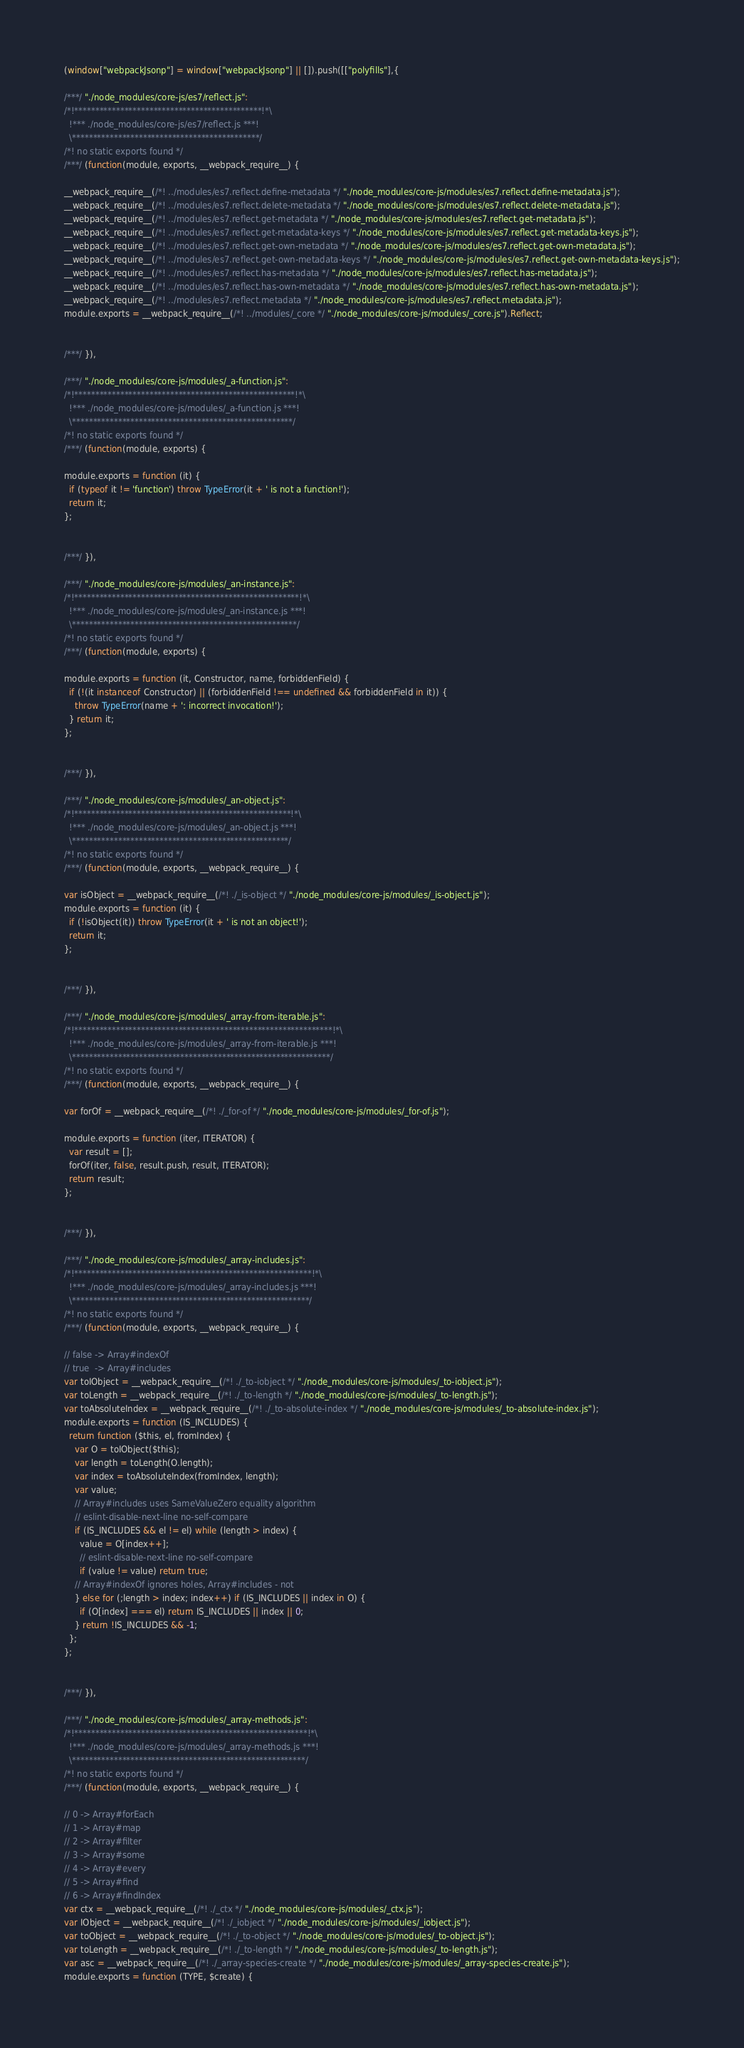Convert code to text. <code><loc_0><loc_0><loc_500><loc_500><_JavaScript_>(window["webpackJsonp"] = window["webpackJsonp"] || []).push([["polyfills"],{

/***/ "./node_modules/core-js/es7/reflect.js":
/*!*********************************************!*\
  !*** ./node_modules/core-js/es7/reflect.js ***!
  \*********************************************/
/*! no static exports found */
/***/ (function(module, exports, __webpack_require__) {

__webpack_require__(/*! ../modules/es7.reflect.define-metadata */ "./node_modules/core-js/modules/es7.reflect.define-metadata.js");
__webpack_require__(/*! ../modules/es7.reflect.delete-metadata */ "./node_modules/core-js/modules/es7.reflect.delete-metadata.js");
__webpack_require__(/*! ../modules/es7.reflect.get-metadata */ "./node_modules/core-js/modules/es7.reflect.get-metadata.js");
__webpack_require__(/*! ../modules/es7.reflect.get-metadata-keys */ "./node_modules/core-js/modules/es7.reflect.get-metadata-keys.js");
__webpack_require__(/*! ../modules/es7.reflect.get-own-metadata */ "./node_modules/core-js/modules/es7.reflect.get-own-metadata.js");
__webpack_require__(/*! ../modules/es7.reflect.get-own-metadata-keys */ "./node_modules/core-js/modules/es7.reflect.get-own-metadata-keys.js");
__webpack_require__(/*! ../modules/es7.reflect.has-metadata */ "./node_modules/core-js/modules/es7.reflect.has-metadata.js");
__webpack_require__(/*! ../modules/es7.reflect.has-own-metadata */ "./node_modules/core-js/modules/es7.reflect.has-own-metadata.js");
__webpack_require__(/*! ../modules/es7.reflect.metadata */ "./node_modules/core-js/modules/es7.reflect.metadata.js");
module.exports = __webpack_require__(/*! ../modules/_core */ "./node_modules/core-js/modules/_core.js").Reflect;


/***/ }),

/***/ "./node_modules/core-js/modules/_a-function.js":
/*!*****************************************************!*\
  !*** ./node_modules/core-js/modules/_a-function.js ***!
  \*****************************************************/
/*! no static exports found */
/***/ (function(module, exports) {

module.exports = function (it) {
  if (typeof it != 'function') throw TypeError(it + ' is not a function!');
  return it;
};


/***/ }),

/***/ "./node_modules/core-js/modules/_an-instance.js":
/*!******************************************************!*\
  !*** ./node_modules/core-js/modules/_an-instance.js ***!
  \******************************************************/
/*! no static exports found */
/***/ (function(module, exports) {

module.exports = function (it, Constructor, name, forbiddenField) {
  if (!(it instanceof Constructor) || (forbiddenField !== undefined && forbiddenField in it)) {
    throw TypeError(name + ': incorrect invocation!');
  } return it;
};


/***/ }),

/***/ "./node_modules/core-js/modules/_an-object.js":
/*!****************************************************!*\
  !*** ./node_modules/core-js/modules/_an-object.js ***!
  \****************************************************/
/*! no static exports found */
/***/ (function(module, exports, __webpack_require__) {

var isObject = __webpack_require__(/*! ./_is-object */ "./node_modules/core-js/modules/_is-object.js");
module.exports = function (it) {
  if (!isObject(it)) throw TypeError(it + ' is not an object!');
  return it;
};


/***/ }),

/***/ "./node_modules/core-js/modules/_array-from-iterable.js":
/*!**************************************************************!*\
  !*** ./node_modules/core-js/modules/_array-from-iterable.js ***!
  \**************************************************************/
/*! no static exports found */
/***/ (function(module, exports, __webpack_require__) {

var forOf = __webpack_require__(/*! ./_for-of */ "./node_modules/core-js/modules/_for-of.js");

module.exports = function (iter, ITERATOR) {
  var result = [];
  forOf(iter, false, result.push, result, ITERATOR);
  return result;
};


/***/ }),

/***/ "./node_modules/core-js/modules/_array-includes.js":
/*!*********************************************************!*\
  !*** ./node_modules/core-js/modules/_array-includes.js ***!
  \*********************************************************/
/*! no static exports found */
/***/ (function(module, exports, __webpack_require__) {

// false -> Array#indexOf
// true  -> Array#includes
var toIObject = __webpack_require__(/*! ./_to-iobject */ "./node_modules/core-js/modules/_to-iobject.js");
var toLength = __webpack_require__(/*! ./_to-length */ "./node_modules/core-js/modules/_to-length.js");
var toAbsoluteIndex = __webpack_require__(/*! ./_to-absolute-index */ "./node_modules/core-js/modules/_to-absolute-index.js");
module.exports = function (IS_INCLUDES) {
  return function ($this, el, fromIndex) {
    var O = toIObject($this);
    var length = toLength(O.length);
    var index = toAbsoluteIndex(fromIndex, length);
    var value;
    // Array#includes uses SameValueZero equality algorithm
    // eslint-disable-next-line no-self-compare
    if (IS_INCLUDES && el != el) while (length > index) {
      value = O[index++];
      // eslint-disable-next-line no-self-compare
      if (value != value) return true;
    // Array#indexOf ignores holes, Array#includes - not
    } else for (;length > index; index++) if (IS_INCLUDES || index in O) {
      if (O[index] === el) return IS_INCLUDES || index || 0;
    } return !IS_INCLUDES && -1;
  };
};


/***/ }),

/***/ "./node_modules/core-js/modules/_array-methods.js":
/*!********************************************************!*\
  !*** ./node_modules/core-js/modules/_array-methods.js ***!
  \********************************************************/
/*! no static exports found */
/***/ (function(module, exports, __webpack_require__) {

// 0 -> Array#forEach
// 1 -> Array#map
// 2 -> Array#filter
// 3 -> Array#some
// 4 -> Array#every
// 5 -> Array#find
// 6 -> Array#findIndex
var ctx = __webpack_require__(/*! ./_ctx */ "./node_modules/core-js/modules/_ctx.js");
var IObject = __webpack_require__(/*! ./_iobject */ "./node_modules/core-js/modules/_iobject.js");
var toObject = __webpack_require__(/*! ./_to-object */ "./node_modules/core-js/modules/_to-object.js");
var toLength = __webpack_require__(/*! ./_to-length */ "./node_modules/core-js/modules/_to-length.js");
var asc = __webpack_require__(/*! ./_array-species-create */ "./node_modules/core-js/modules/_array-species-create.js");
module.exports = function (TYPE, $create) {</code> 